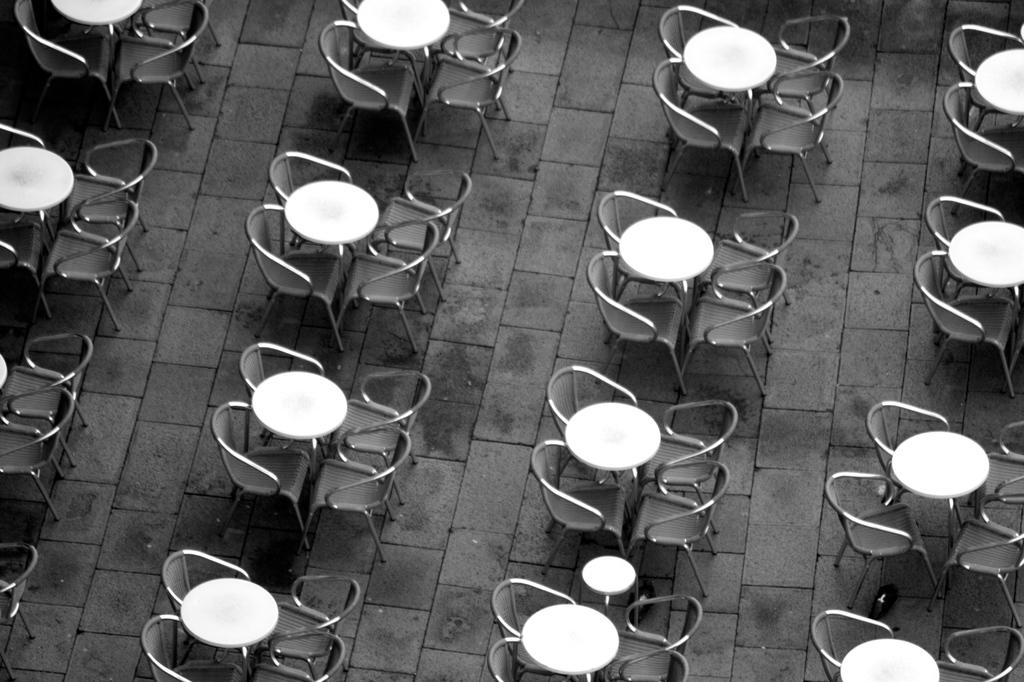What is the color scheme of the image? The image is black and white. What type of furniture can be seen in the image? There are tables and chairs in the image. What part of the room is visible in the background? The floor is visible in the background of the image. Where is the box located in the image? There is no box present in the image. What type of arm can be seen attached to the chair in the image? There is no arm attached to the chair in the image; only the chair itself is visible. 